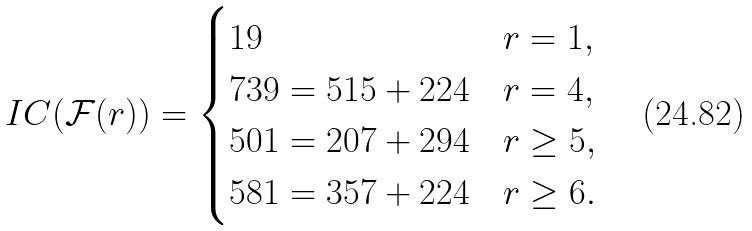<formula> <loc_0><loc_0><loc_500><loc_500>I C ( \mathcal { F } ( r ) ) = \begin{cases} 1 9 & r = 1 , \\ 7 3 9 = 5 1 5 + 2 2 4 & r = 4 , \\ 5 0 1 = 2 0 7 + 2 9 4 & r \geq 5 , \\ 5 8 1 = 3 5 7 + 2 2 4 & r \geq 6 . \end{cases}</formula> 